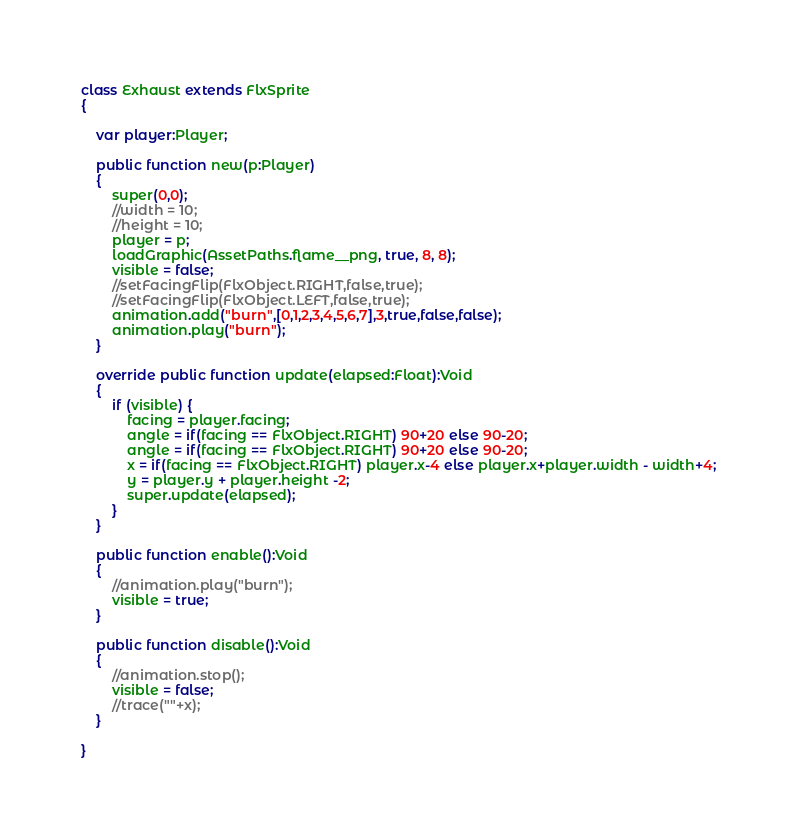Convert code to text. <code><loc_0><loc_0><loc_500><loc_500><_Haxe_>
class Exhaust extends FlxSprite
{

    var player:Player;

    public function new(p:Player)
    {
        super(0,0);
        //width = 10;
        //height = 10;
        player = p;
        loadGraphic(AssetPaths.flame__png, true, 8, 8);
        visible = false;
        //setFacingFlip(FlxObject.RIGHT,false,true);
        //setFacingFlip(FlxObject.LEFT,false,true);
        animation.add("burn",[0,1,2,3,4,5,6,7],3,true,false,false);
        animation.play("burn");
    }

    override public function update(elapsed:Float):Void
    {
        if (visible) {
            facing = player.facing;
            angle = if(facing == FlxObject.RIGHT) 90+20 else 90-20;
            angle = if(facing == FlxObject.RIGHT) 90+20 else 90-20;
            x = if(facing == FlxObject.RIGHT) player.x-4 else player.x+player.width - width+4;
            y = player.y + player.height -2;
            super.update(elapsed);
        }
    }

    public function enable():Void
    {
        //animation.play("burn");
        visible = true;
    }

    public function disable():Void
    {
        //animation.stop();
        visible = false;
        //trace(""+x);
    }

}</code> 